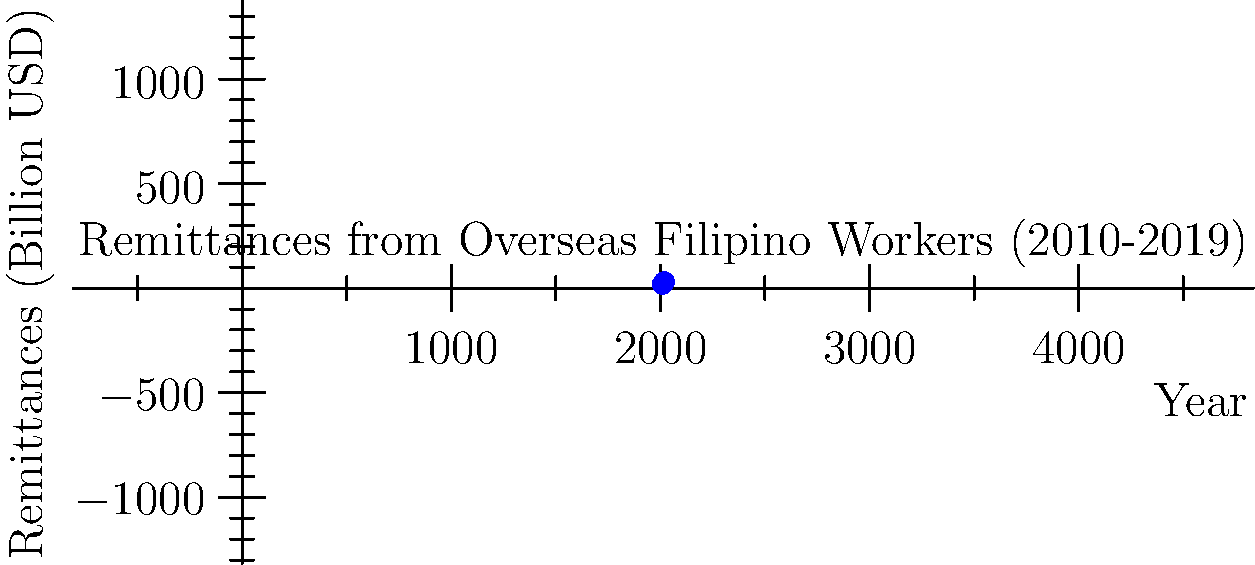Based on the infographic showing remittances from Overseas Filipino Workers (OFWs) from 2010 to 2019, what was the approximate percentage increase in remittances between 2010 and 2019? To calculate the percentage increase in remittances between 2010 and 2019:

1. Identify the remittance values:
   2010: $18.76 billion
   2019: $30.13 billion

2. Calculate the difference:
   $30.13 - $18.76 = $11.37 billion

3. Divide the difference by the 2010 value:
   $11.37 / $18.76 = 0.6061

4. Convert to percentage:
   0.6061 * 100 = 60.61%

Therefore, the approximate percentage increase in remittances from OFWs between 2010 and 2019 was 60.61%, or roughly 61%.
Answer: 61% 